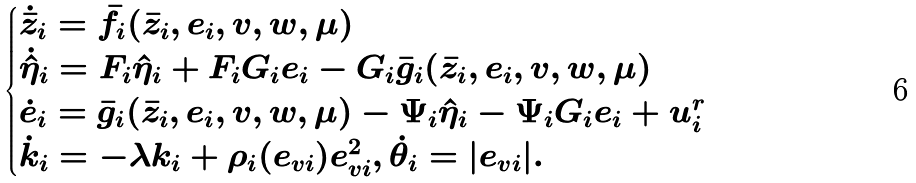<formula> <loc_0><loc_0><loc_500><loc_500>\begin{cases} \dot { \bar { z } } _ { i } = \bar { f } _ { i } ( \bar { z } _ { i } , e _ { i } , v , w , \mu ) \\ \dot { \hat { \eta } } _ { i } = F _ { i } \hat { \eta } _ { i } + F _ { i } G _ { i } e _ { i } - G _ { i } \bar { g } _ { i } ( \bar { z } _ { i } , e _ { i } , v , w , \mu ) \\ \dot { e } _ { i } = \bar { g } _ { i } ( \bar { z } _ { i } , e _ { i } , v , w , \mu ) - \Psi _ { i } \hat { \eta } _ { i } - \Psi _ { i } G _ { i } e _ { i } + u _ { i } ^ { r } \\ \dot { k } _ { i } = - \lambda k _ { i } + \rho _ { i } ( e _ { v i } ) e _ { v i } ^ { 2 } , \dot { \theta } _ { i } = | e _ { v i } | . \end{cases}</formula> 